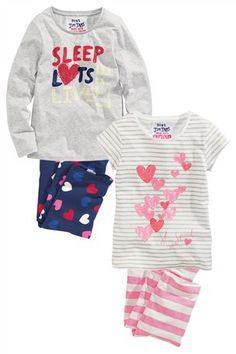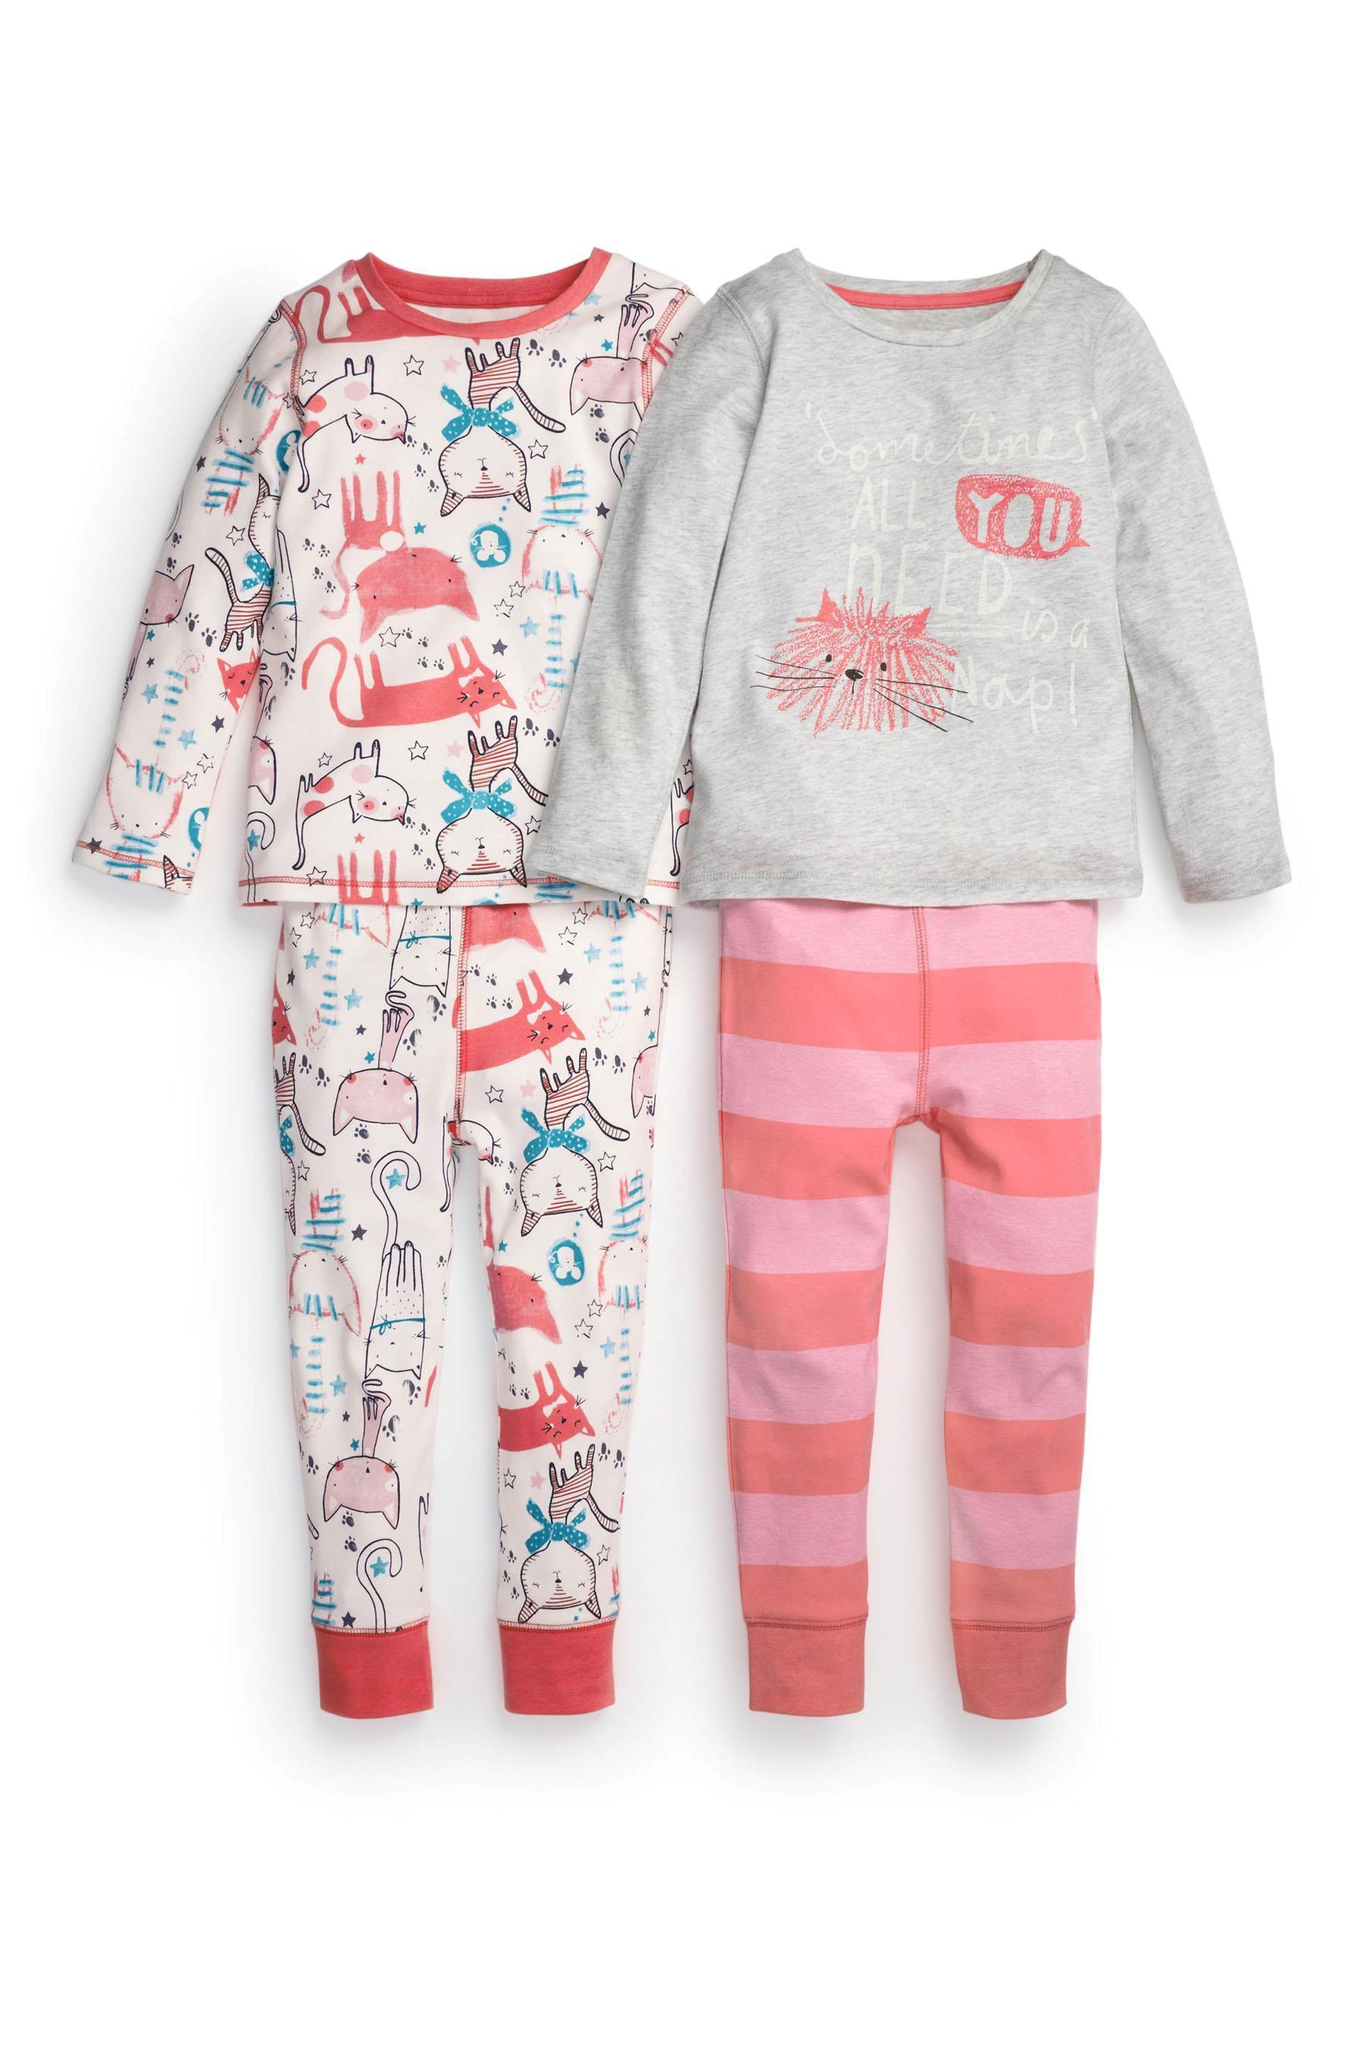The first image is the image on the left, the second image is the image on the right. For the images shown, is this caption "An image includes a short-sleeve top and a pair of striped pants." true? Answer yes or no. Yes. The first image is the image on the left, the second image is the image on the right. Analyze the images presented: Is the assertion "None of the pants have vertical or horizontal stripes." valid? Answer yes or no. No. 